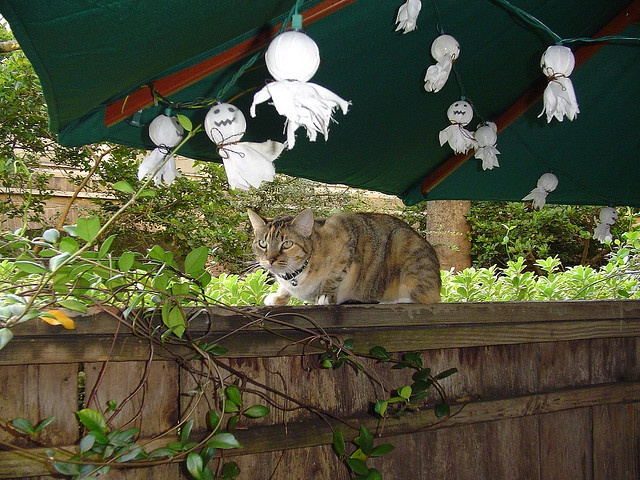Describe the objects in this image and their specific colors. I can see umbrella in black, white, darkgray, and maroon tones and cat in black, olive, gray, and tan tones in this image. 